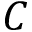<formula> <loc_0><loc_0><loc_500><loc_500>C</formula> 